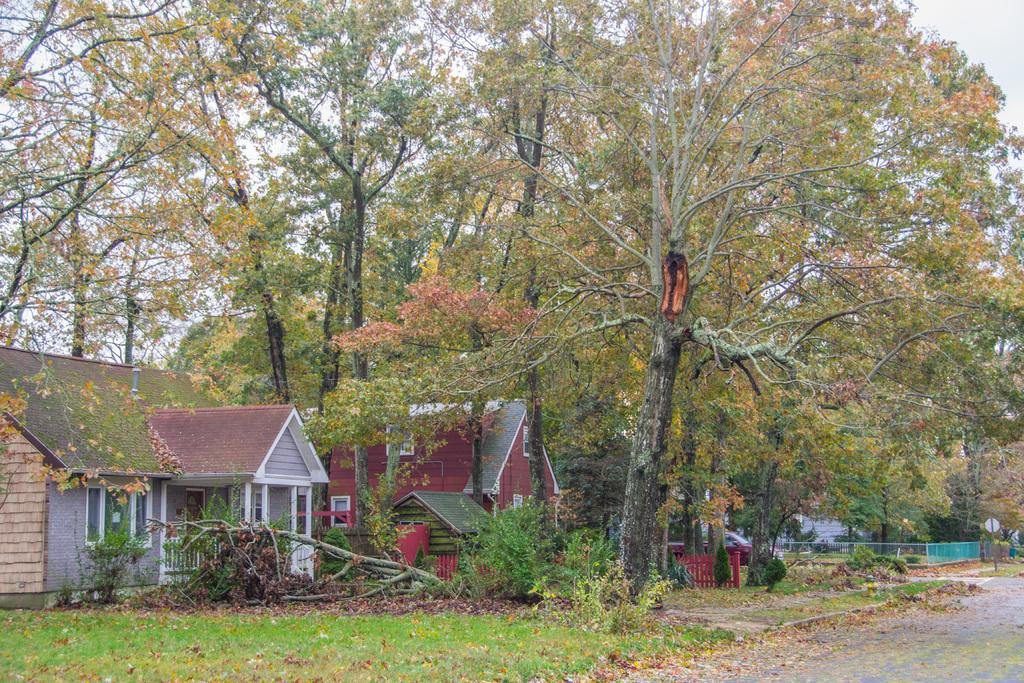What type of structures can be seen in the image? There are buildings in the image. What natural elements are present in the image? There are trees and plants in the image. What man-made feature is visible in the image? There is a road in the image. What is the condition of the sky in the image? The sky is clear in the image. Can you tell me how much milk your aunt is carrying in the image? There is no aunt or milk present in the image. What type of assistance is being provided by the person in the image? There is no person providing help in the image; it only features buildings, trees, plants, a road, and a clear sky. 